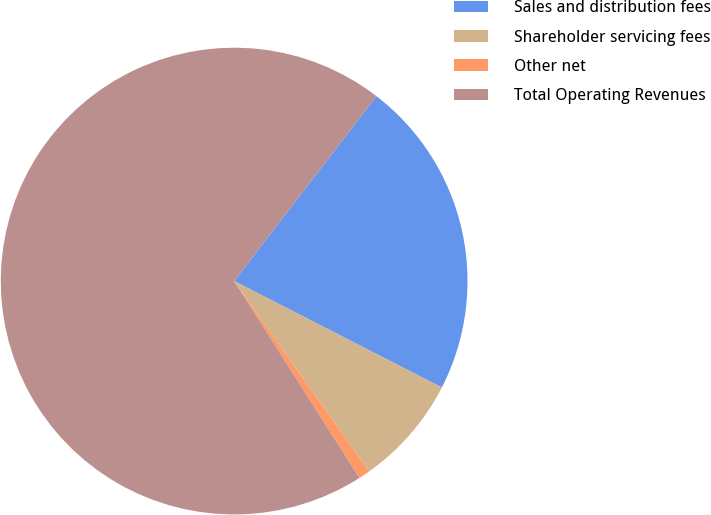Convert chart. <chart><loc_0><loc_0><loc_500><loc_500><pie_chart><fcel>Sales and distribution fees<fcel>Shareholder servicing fees<fcel>Other net<fcel>Total Operating Revenues<nl><fcel>22.1%<fcel>7.65%<fcel>0.79%<fcel>69.46%<nl></chart> 